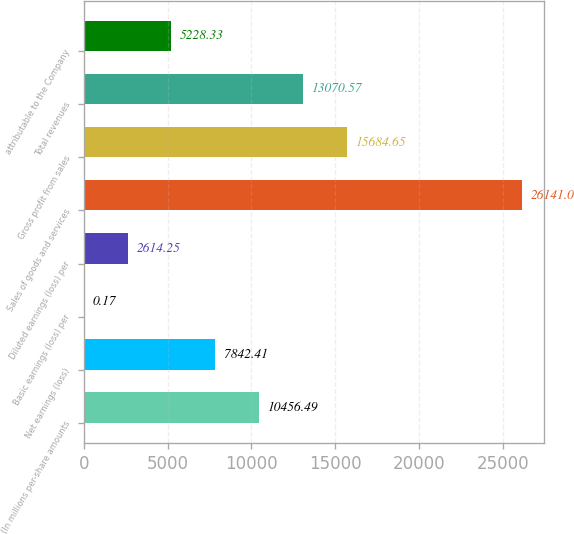Convert chart. <chart><loc_0><loc_0><loc_500><loc_500><bar_chart><fcel>(In millions per-share amounts<fcel>Net earnings (loss)<fcel>Basic earnings (loss) per<fcel>Diluted earnings (loss) per<fcel>Sales of goods and services<fcel>Gross profit from sales<fcel>Total revenues<fcel>attributable to the Company<nl><fcel>10456.5<fcel>7842.41<fcel>0.17<fcel>2614.25<fcel>26141<fcel>15684.6<fcel>13070.6<fcel>5228.33<nl></chart> 